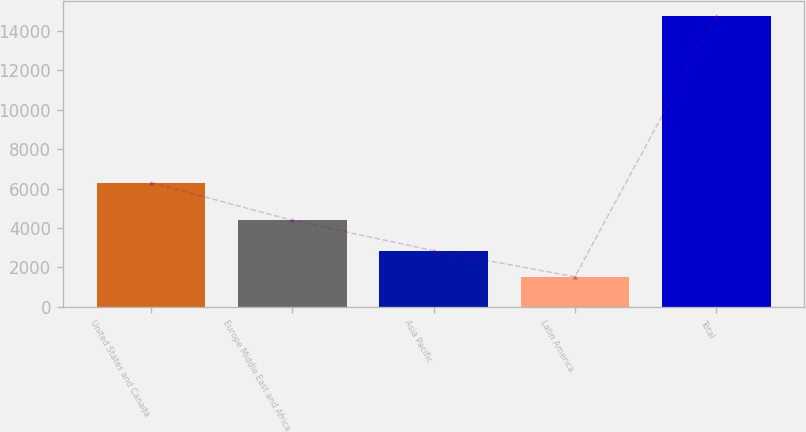Convert chart. <chart><loc_0><loc_0><loc_500><loc_500><bar_chart><fcel>United States and Canada<fcel>Europe Middle East and Africa<fcel>Asia Pacific<fcel>Latin America<fcel>Total<nl><fcel>6307<fcel>4389<fcel>2850.9<fcel>1529<fcel>14748<nl></chart> 